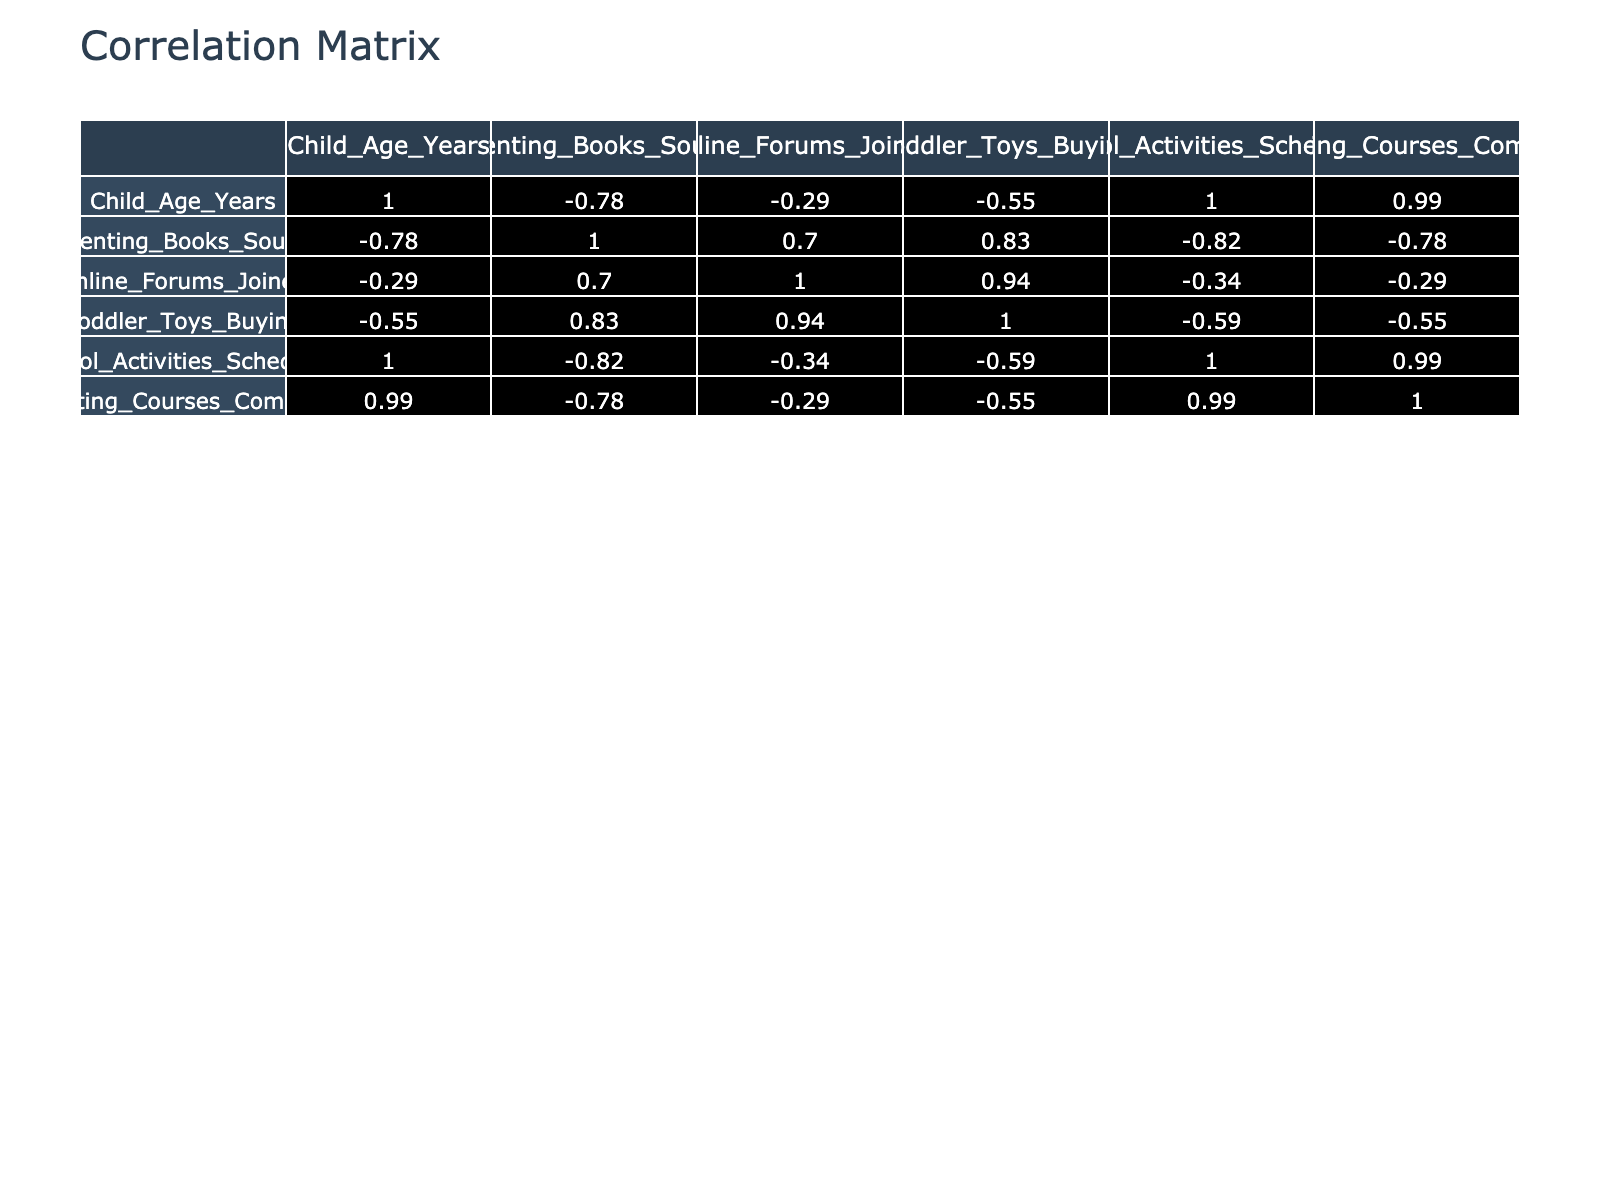What is the correlation between the age of children and the number of parenting books sought? To find the correlation value, examine the cell in the correlation matrix where the row for "Child_Age_Years" intersects with the column for "Parenting_Books_Sought." This value is 0.80, indicating a strong positive correlation.
Answer: 0.80 How many online forums do parents with 3-year-old children typically join? By locating the row for 3 years in the table, we check the value under the "Online_Forums_Joined" column. For 3-year-olds, the value is 8.
Answer: 8 Is it true that as children get older, parents tend to buy fewer toddler toys? Looking at the correlation between "Child_Age_Years" and "Toddler_Toys_Buying," we find a correlation of -0.94, which indicates a strong negative correlation, confirming that parents buy fewer toddler toys as children age.
Answer: Yes What is the average number of school activities scheduled for children aged 5 to 10? Find the values for "School_Activities_Scheduled" for children aged 5, 6, 7, 8, 9, and 10, which are 4, 5, 6, 8, 9, and 10 respectively. Adding them gives 42. There are 6 age groups, so the average is 42/6 = 7.
Answer: 7 What is the relationship between the completion of parenting courses and the age of children? The correlation between "Child_Age_Years" and "Parenting_Courses_Completed" is 0.83. This shows that as children grow older, parents are more likely to complete parenting courses, revealing a strong positive correlation.
Answer: 0.83 Do parents with older children typically seek out more resources like parenting books? Referring to the correlation value between "Child_Age_Years" and "Parenting_Books_Sought," which is 0.80, the data supports that parents of older children tend to seek out more resources, confirming the statement to be true.
Answer: Yes Which age group shows the highest average number of toys purchased? We need to calculate the average number of toddler toys bought for each age group. The numbers are 20, 18, 22, 25, 30, 35, 38, 40, 30, 25, 20, 15, 12, 10, 8, and 5 for ages 0 through 15 respectively. The average for these numbers is 21.5, making age 5 have the highest toy purchases.
Answer: 35 What is the total number of parenting courses completed by parents with children aged 0 to 4? We sum the values for "Parenting_Courses_Completed" for the ages 0 to 4, which are 1, 1, 2, 2, and 3 respectively. Adding these gives a total of 9.
Answer: 9 